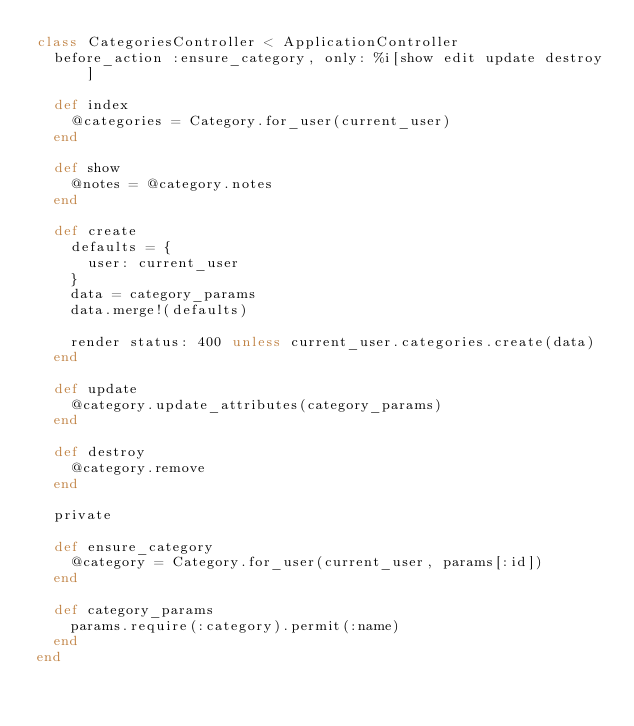Convert code to text. <code><loc_0><loc_0><loc_500><loc_500><_Ruby_>class CategoriesController < ApplicationController
  before_action :ensure_category, only: %i[show edit update destroy]

  def index
    @categories = Category.for_user(current_user)
  end

  def show
    @notes = @category.notes
  end

  def create
    defaults = {
      user: current_user
    }
    data = category_params
    data.merge!(defaults)

    render status: 400 unless current_user.categories.create(data)
  end

  def update
    @category.update_attributes(category_params)
  end

  def destroy
    @category.remove
  end

  private

  def ensure_category
    @category = Category.for_user(current_user, params[:id])
  end

  def category_params
    params.require(:category).permit(:name)
  end
end
</code> 